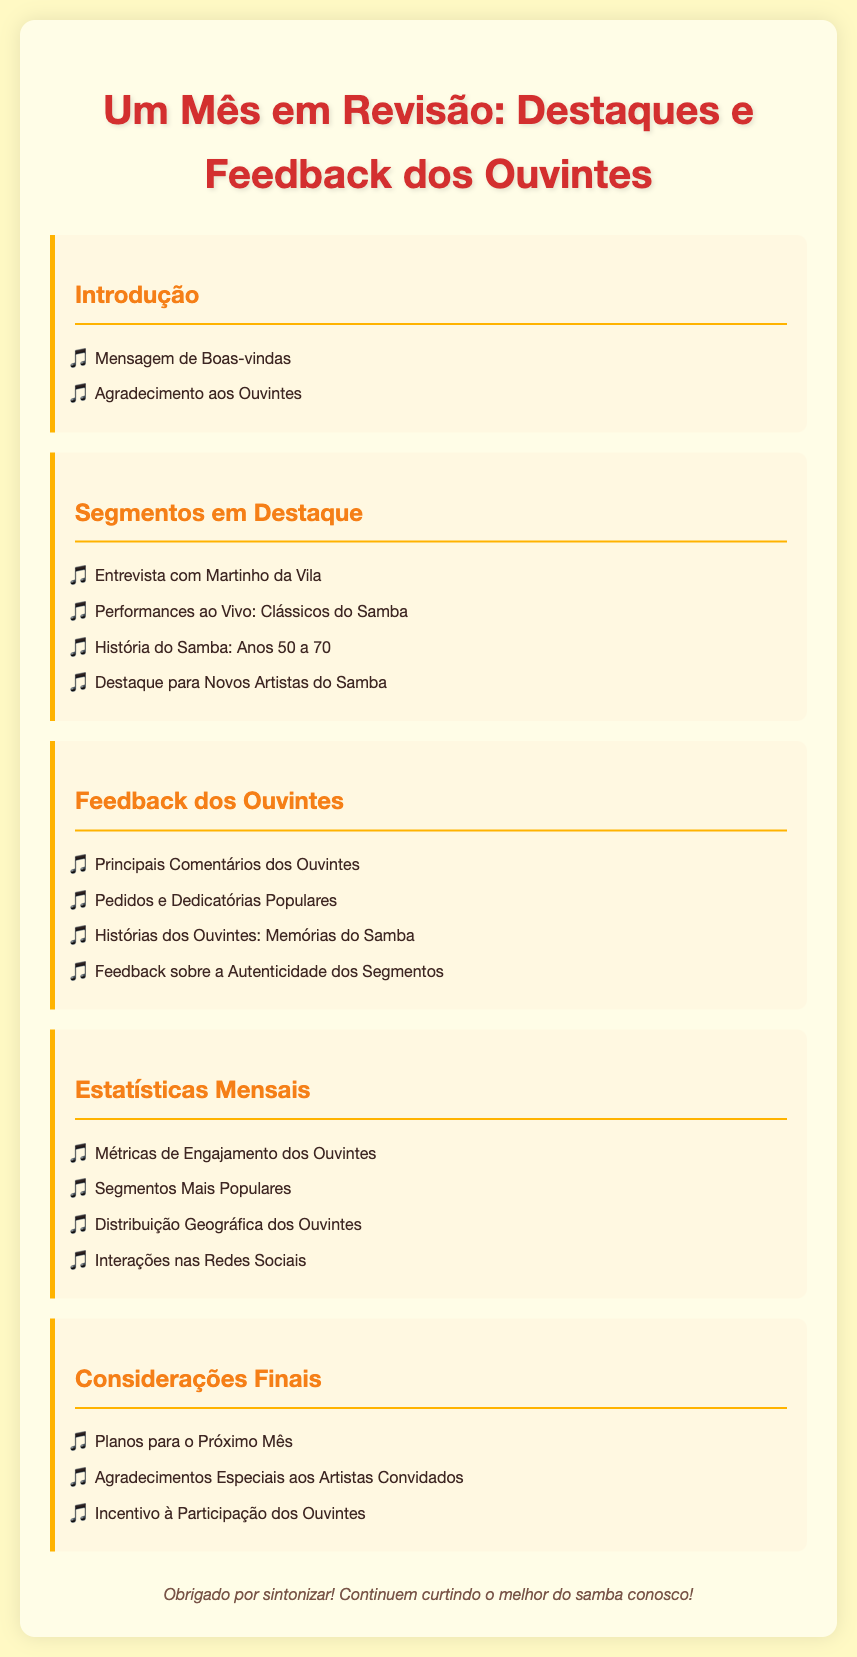qual é o título do documento? O título do documento está claramente apresentado na parte superior do conteúdo.
Answer: Um Mês em Revisão: Destaques e Feedback dos Ouvintes quem foi entrevistado nos segmentos em destaque? A entrevista é mencionada como um dos destaques, revelando o artista entrevistado.
Answer: Martinho da Vila quais anos a história do samba abrange? A história do samba mencionada no documento cobre um intervalo específico.
Answer: Anos 50 a 70 quais são as principais categorias de feedback dos ouvintes? O feedback é dividido em diferentes tópicos, que são explicitados na seção correspondente.
Answer: Principais Comentários dos Ouvintes, Pedidos e Dedicatórias Populares, Histórias dos Ouvintes: Memórias do Samba, Feedback sobre a Autenticidade dos Segmentos quantos segmentos estão destacados no total? A seção de segmentos em destaque lista quatro tópicos, referindo-se a cada evento específico.
Answer: Quatro quais são os principais planos mencionados para o próximo mês? Os planos futuros são introduzidos na seção de considerações finais.
Answer: Planos para o Próximo Mês quais métricas são discutidas na seção de estatísticas mensais? As métricas incluem diferentes tipos de atividades que envolvem a audiência.
Answer: Métricas de Engajamento dos Ouvintes, Segmentos Mais Populares, Distribuição Geográfica dos Ouvintes, Interações nas Redes Sociais quem é homenageado nos agradecimentos especiais? A seção de agradecimentos menciona um grupo específico de contribuição musical.
Answer: Artistas Convidados 